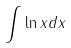Convert formula to latex. <formula><loc_0><loc_0><loc_500><loc_500>\int \ln x d x</formula> 